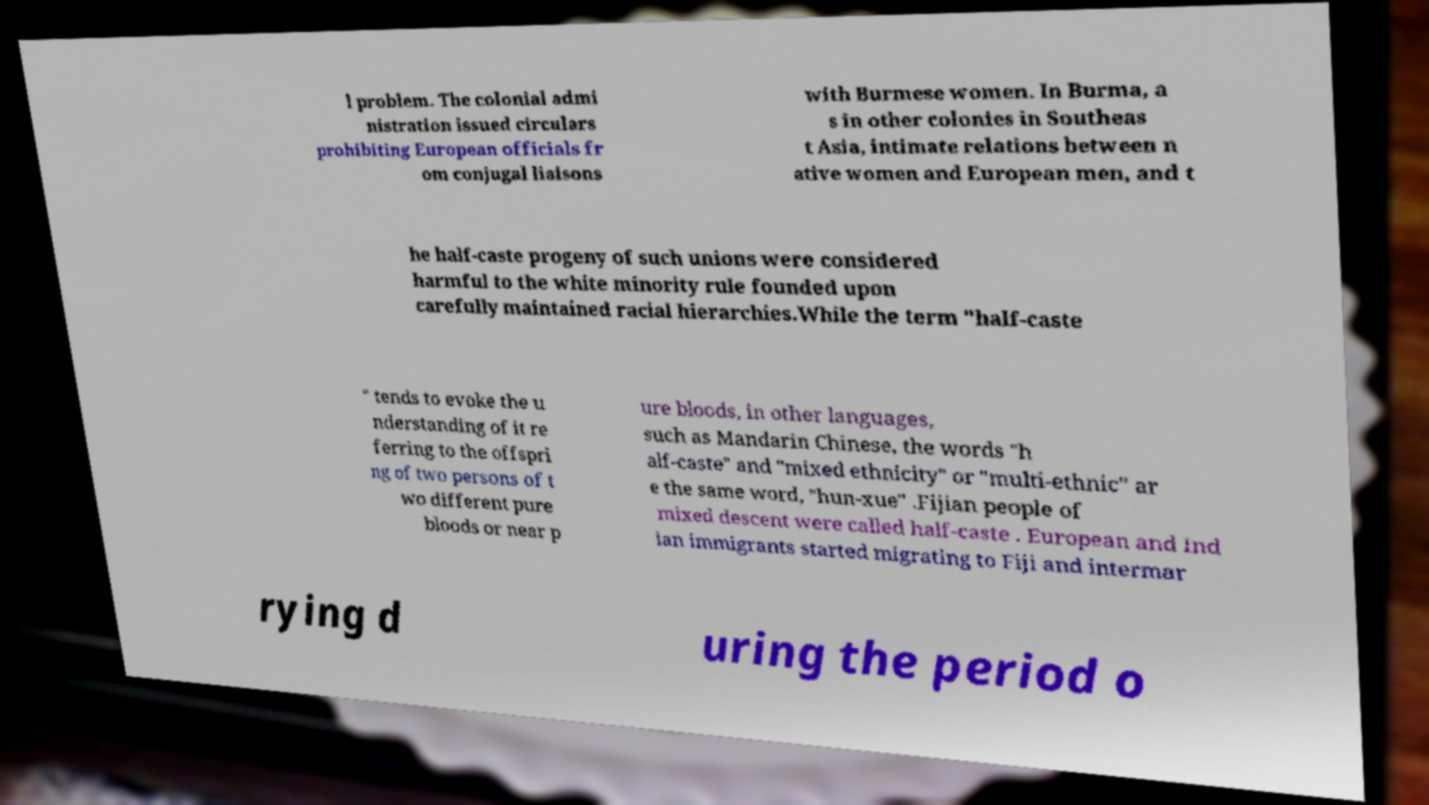Please read and relay the text visible in this image. What does it say? l problem. The colonial admi nistration issued circulars prohibiting European officials fr om conjugal liaisons with Burmese women. In Burma, a s in other colonies in Southeas t Asia, intimate relations between n ative women and European men, and t he half-caste progeny of such unions were considered harmful to the white minority rule founded upon carefully maintained racial hierarchies.While the term "half-caste " tends to evoke the u nderstanding of it re ferring to the offspri ng of two persons of t wo different pure bloods or near p ure bloods, in other languages, such as Mandarin Chinese, the words "h alf-caste" and "mixed ethnicity" or "multi-ethnic" ar e the same word, "hun-xue" .Fijian people of mixed descent were called half-caste . European and Ind ian immigrants started migrating to Fiji and intermar rying d uring the period o 